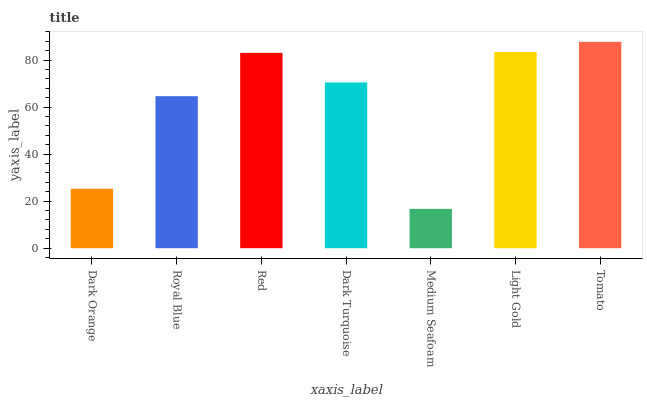Is Medium Seafoam the minimum?
Answer yes or no. Yes. Is Tomato the maximum?
Answer yes or no. Yes. Is Royal Blue the minimum?
Answer yes or no. No. Is Royal Blue the maximum?
Answer yes or no. No. Is Royal Blue greater than Dark Orange?
Answer yes or no. Yes. Is Dark Orange less than Royal Blue?
Answer yes or no. Yes. Is Dark Orange greater than Royal Blue?
Answer yes or no. No. Is Royal Blue less than Dark Orange?
Answer yes or no. No. Is Dark Turquoise the high median?
Answer yes or no. Yes. Is Dark Turquoise the low median?
Answer yes or no. Yes. Is Medium Seafoam the high median?
Answer yes or no. No. Is Red the low median?
Answer yes or no. No. 